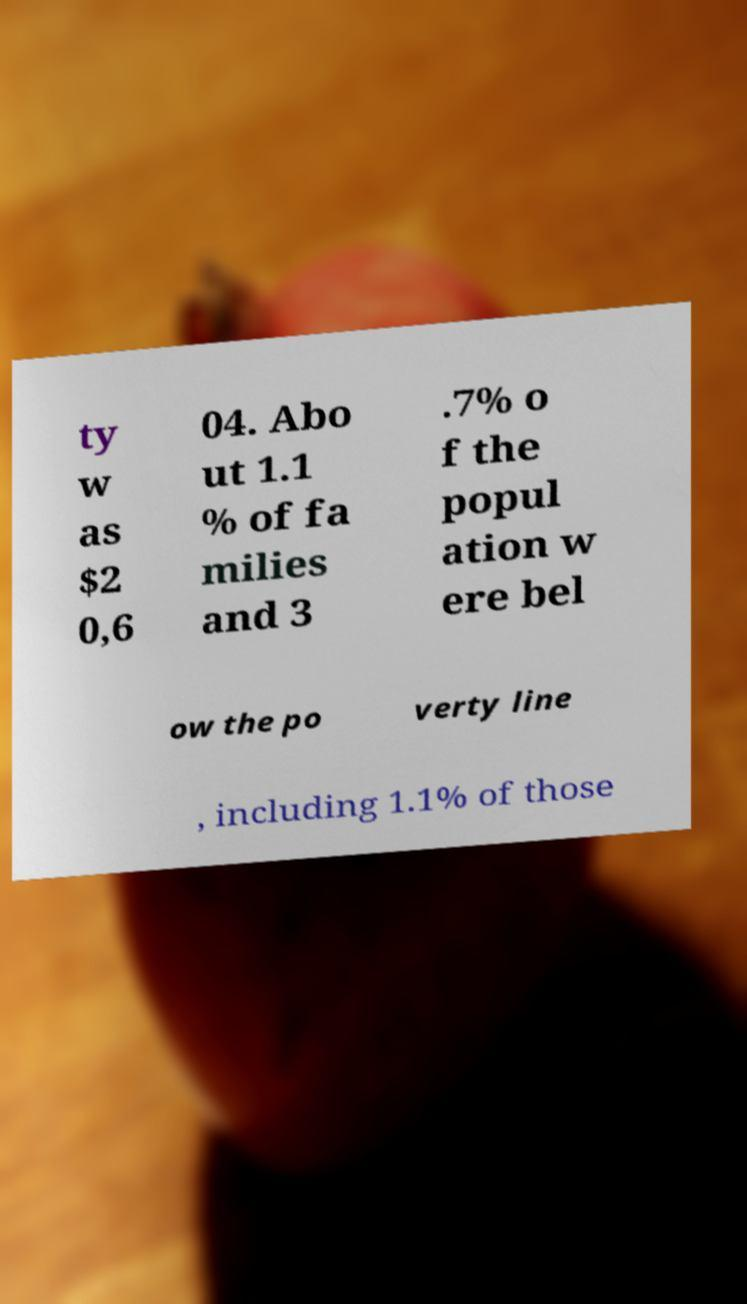I need the written content from this picture converted into text. Can you do that? ty w as $2 0,6 04. Abo ut 1.1 % of fa milies and 3 .7% o f the popul ation w ere bel ow the po verty line , including 1.1% of those 